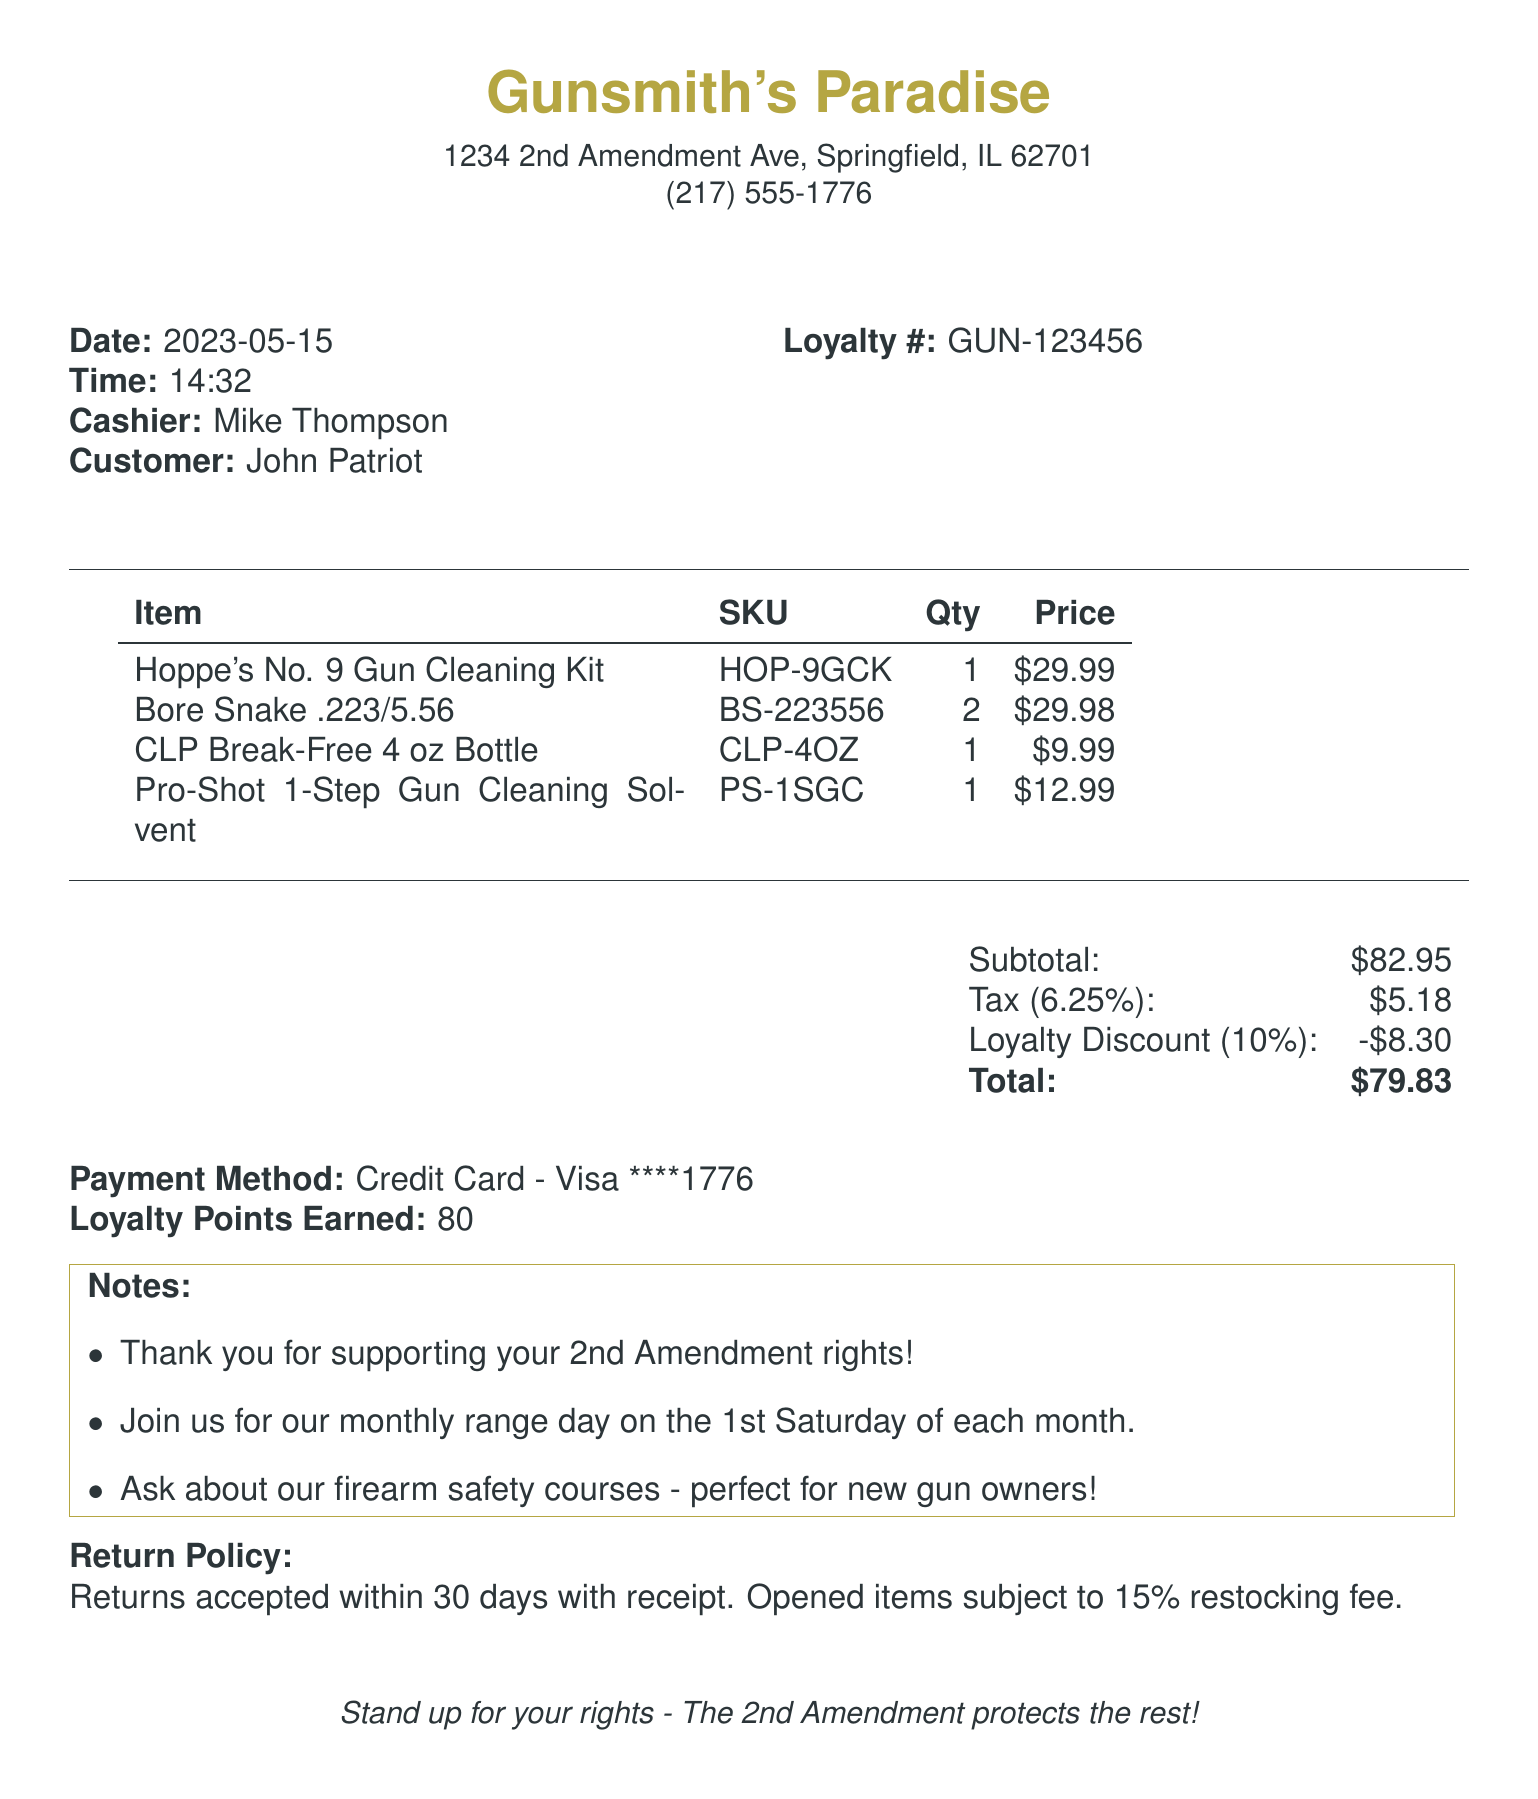What is the store name? The store name is shown prominently at the top of the receipt.
Answer: Gunsmith's Paradise What is the date of the purchase? The date of the purchase is listed in the receipt section dedicated to transaction details.
Answer: 2023-05-15 Who was the cashier? The cashier's name is specified in the receipt under transaction details.
Answer: Mike Thompson What is the SKU for the Bore Snake? The SKU is listed next to the item name in the table of items purchased.
Answer: BS-223556 What was the loyalty discount amount? The loyalty discount amount is provided under the total cost section.
Answer: 8.30 How many loyalty points were earned? The total loyalty points earned is stated near the payment information.
Answer: 80 What is the return policy duration? The return policy information is clearly stated at the end of the receipt.
Answer: 30 days What is the total amount paid? The total amount is calculated and printed in bold in the total cost section.
Answer: 79.83 How many Bore Snakes were purchased? The quantity for each item is listed in the item purchase table.
Answer: 2 